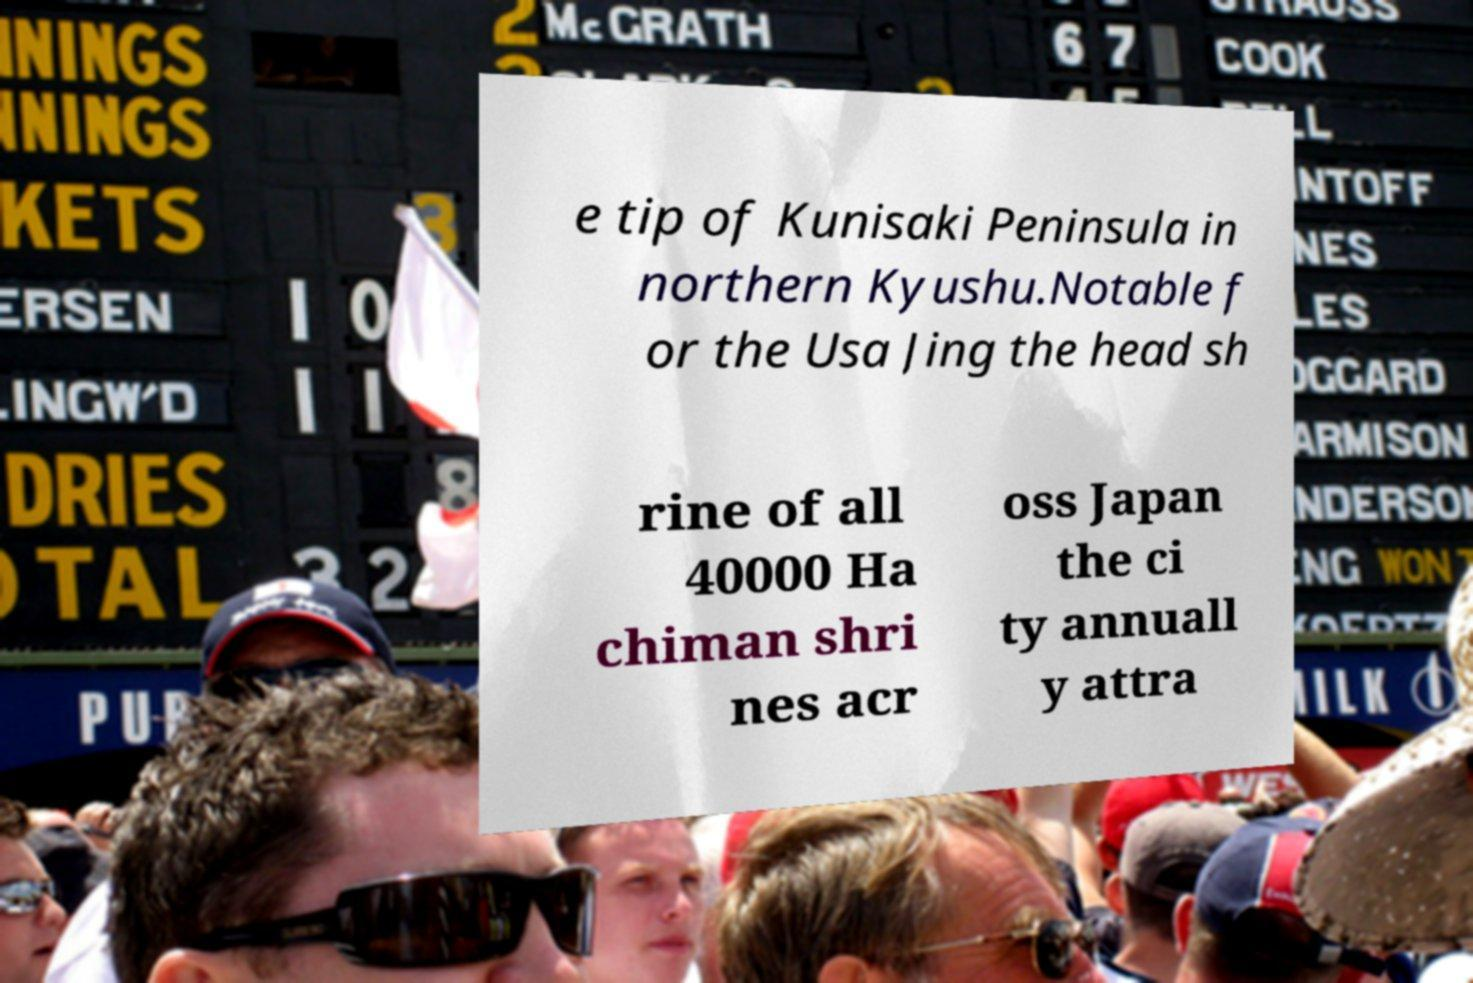Please identify and transcribe the text found in this image. e tip of Kunisaki Peninsula in northern Kyushu.Notable f or the Usa Jing the head sh rine of all 40000 Ha chiman shri nes acr oss Japan the ci ty annuall y attra 